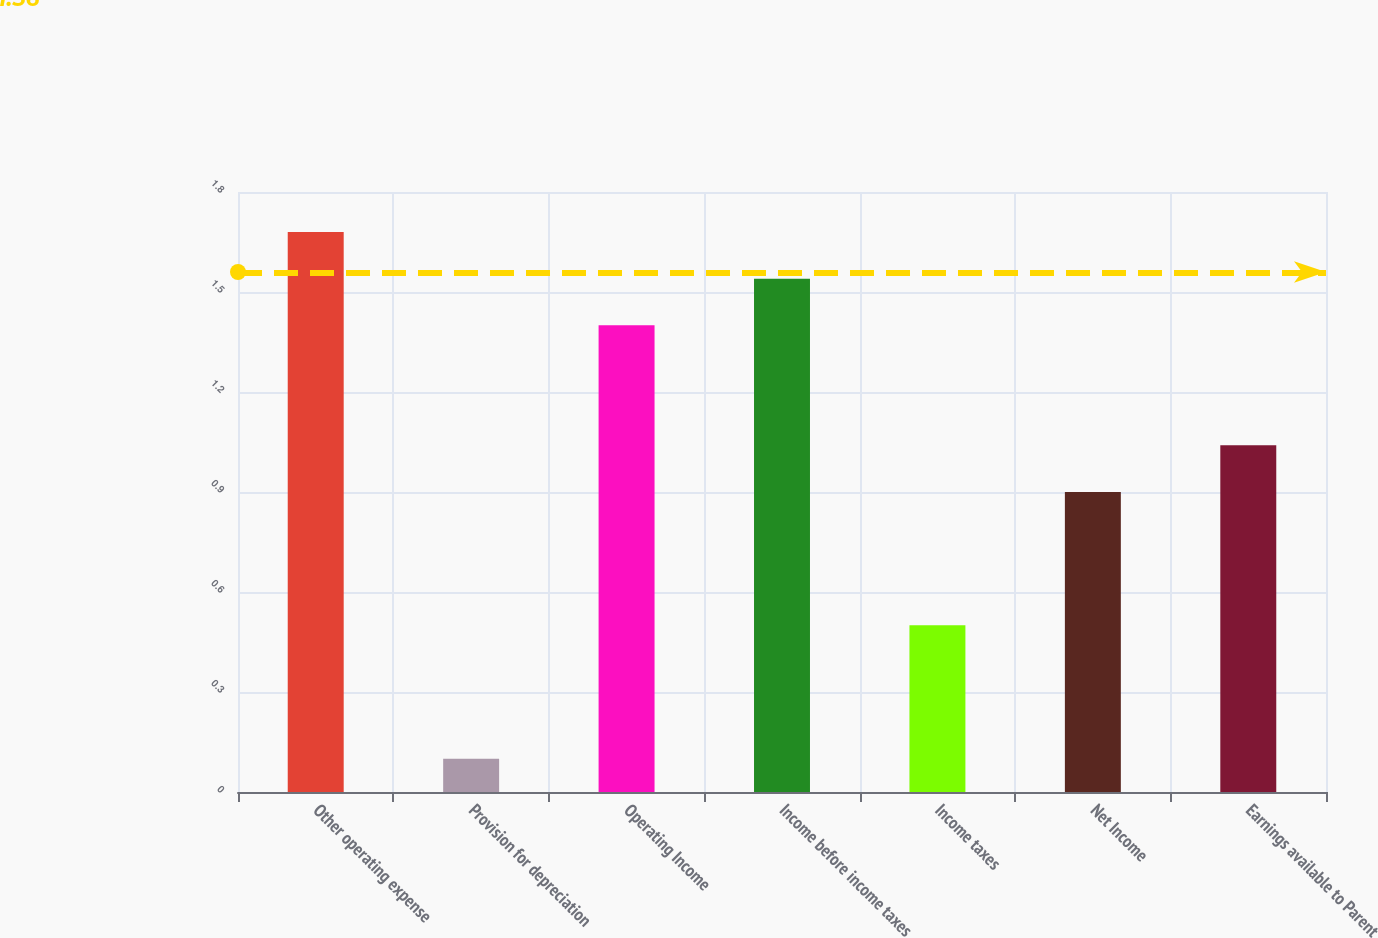<chart> <loc_0><loc_0><loc_500><loc_500><bar_chart><fcel>Other operating expense<fcel>Provision for depreciation<fcel>Operating Income<fcel>Income before income taxes<fcel>Income taxes<fcel>Net Income<fcel>Earnings available to Parent<nl><fcel>1.68<fcel>0.1<fcel>1.4<fcel>1.54<fcel>0.5<fcel>0.9<fcel>1.04<nl></chart> 